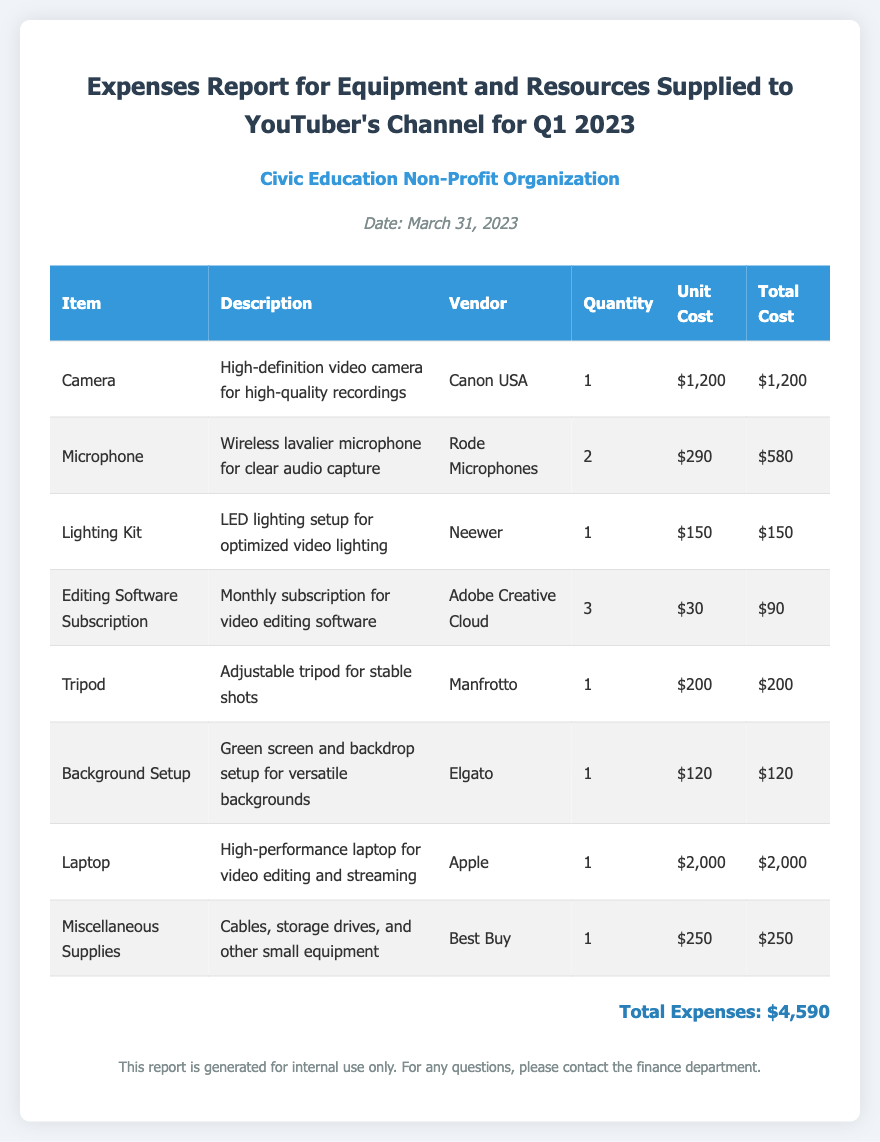what is the total cost for the Microphone? The total cost for the Microphone is mentioned specifically in the table as $580.
Answer: $580 how many items were purchased in this report? The total items purchased can be calculated from the number of rows in the table, which shows 8 entries.
Answer: 8 who is the vendor for the Lighting Kit? The vendor for the Lighting Kit is identified in the table as Neewer.
Answer: Neewer what is the unit cost of the Laptop? The unit cost of the Laptop is provided in the document as $2,000.
Answer: $2,000 which item has the highest total cost? The item with the highest total cost is determined by comparing the total costs listed, which shows that the Laptop at $2,000 is the highest.
Answer: Laptop how much was spent on Miscellaneous Supplies? The cost allocated for Miscellaneous Supplies is given as $250 in the document.
Answer: $250 when was the report generated? The report was generated on March 31, 2023, as indicated at the top of the document.
Answer: March 31, 2023 what is the total expense for Q1 2023? The total expense for Q1 2023 is stated in the document as $4,590.
Answer: $4,590 